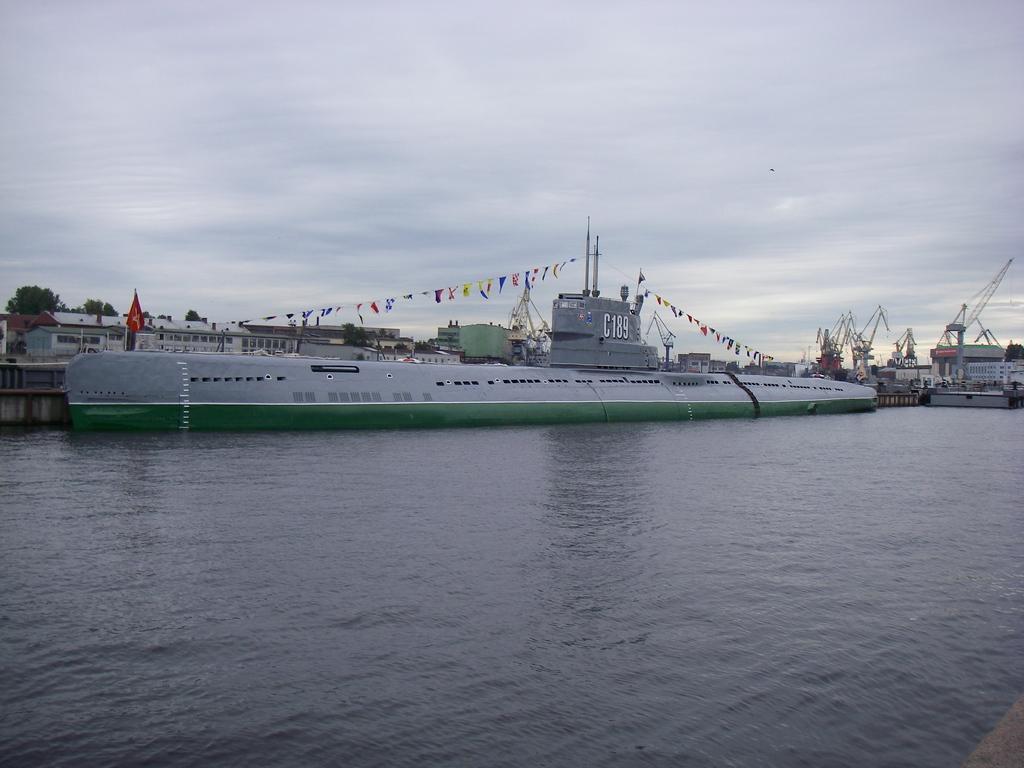Please provide a concise description of this image. In this picture I can see there is a submarine here on the water and in the backdrop there are trees, buildings and the sky is clear. 